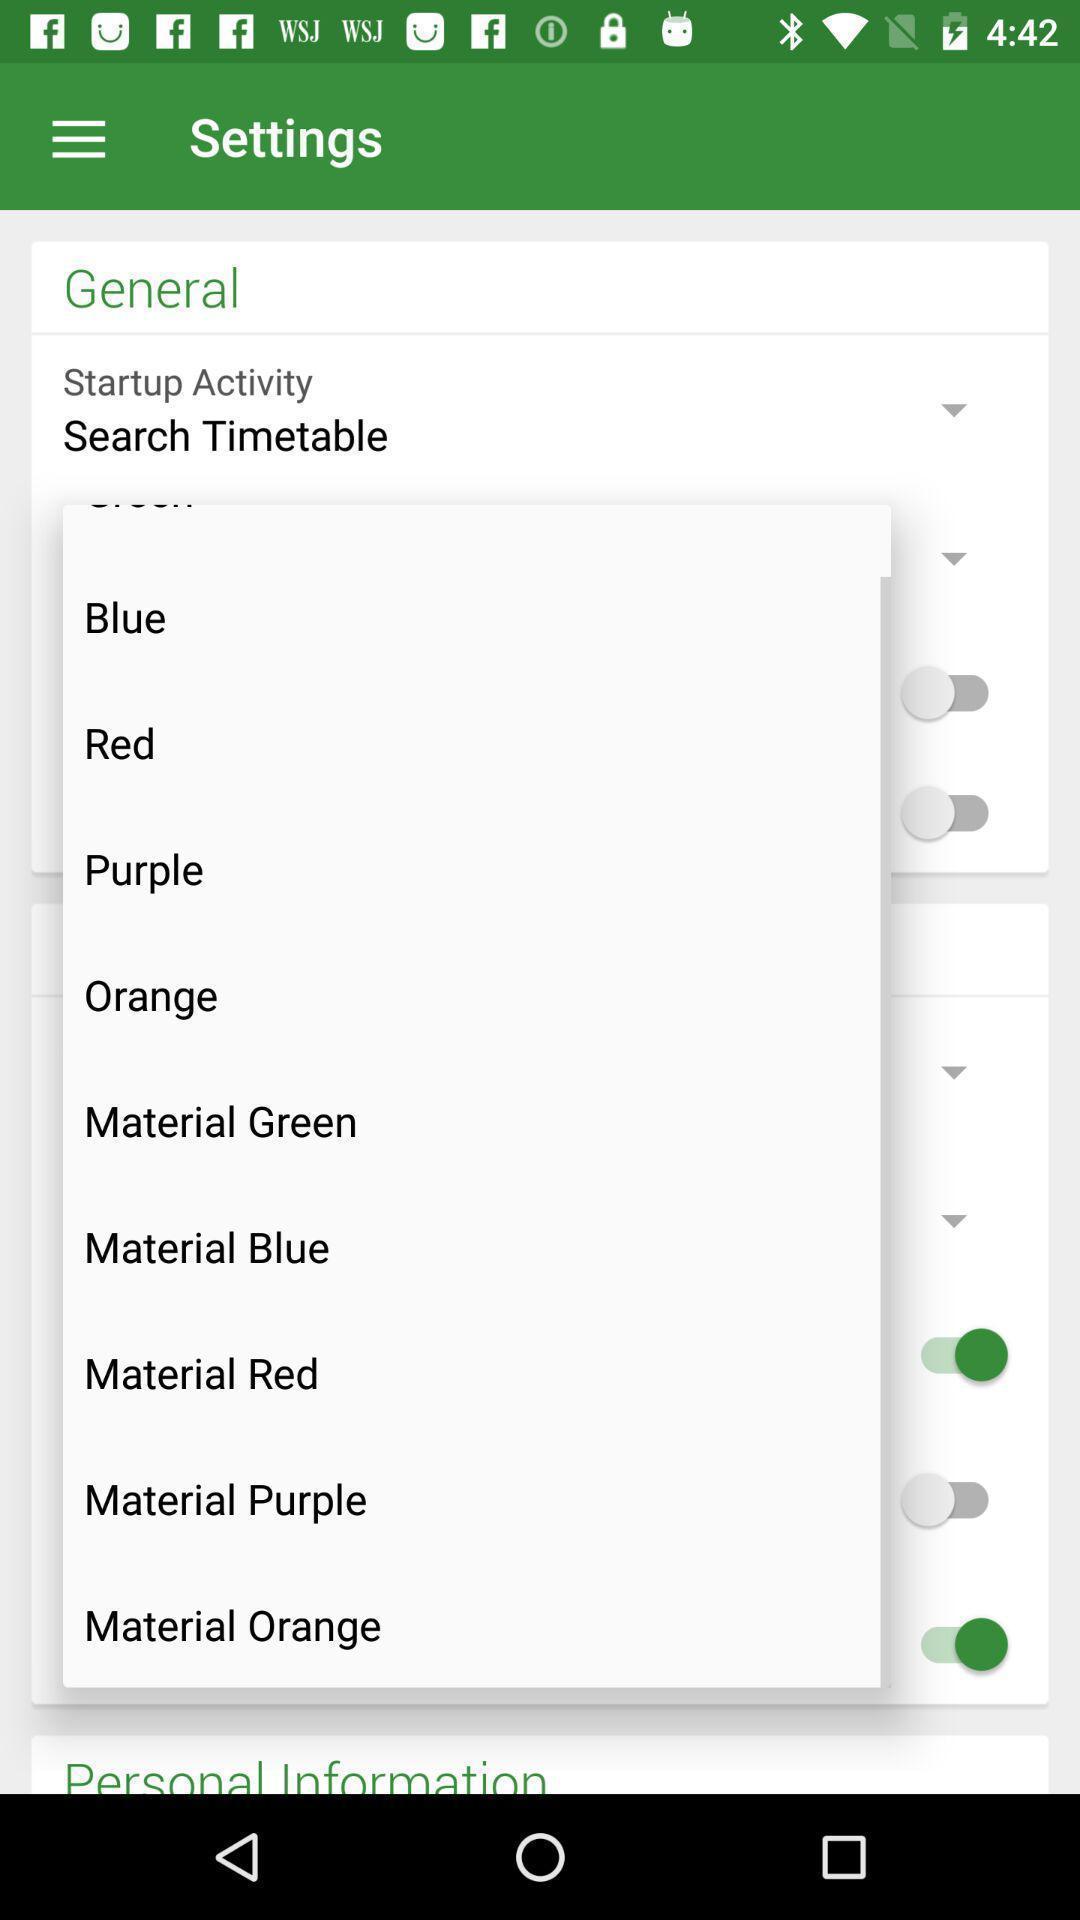Give me a summary of this screen capture. Page showing settings in a transit info app. 